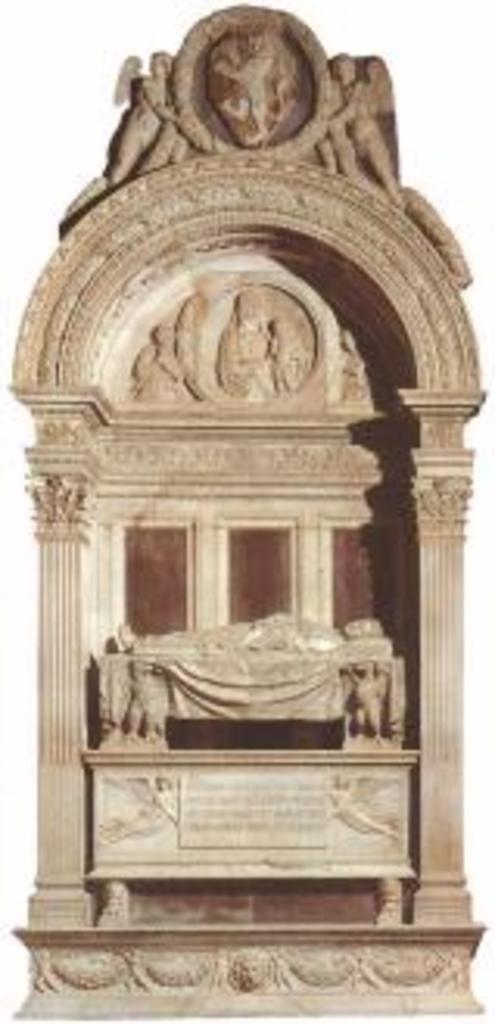What is depicted on the stone in the image? There is a carving on a stone in the image. What color is the background of the image? The background of the image is white. What type of cup can be seen falling off the railway during the earthquake in the image? There is no cup, railway, or earthquake present in the image. The image only features a carving on a stone with a white background. 